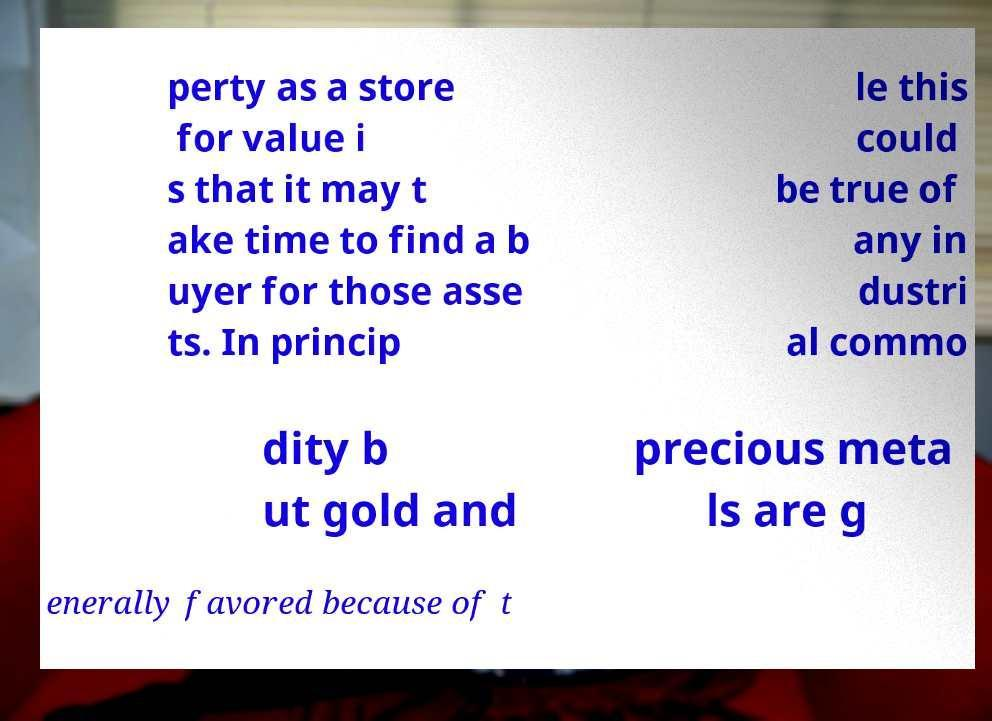Can you accurately transcribe the text from the provided image for me? perty as a store for value i s that it may t ake time to find a b uyer for those asse ts. In princip le this could be true of any in dustri al commo dity b ut gold and precious meta ls are g enerally favored because of t 